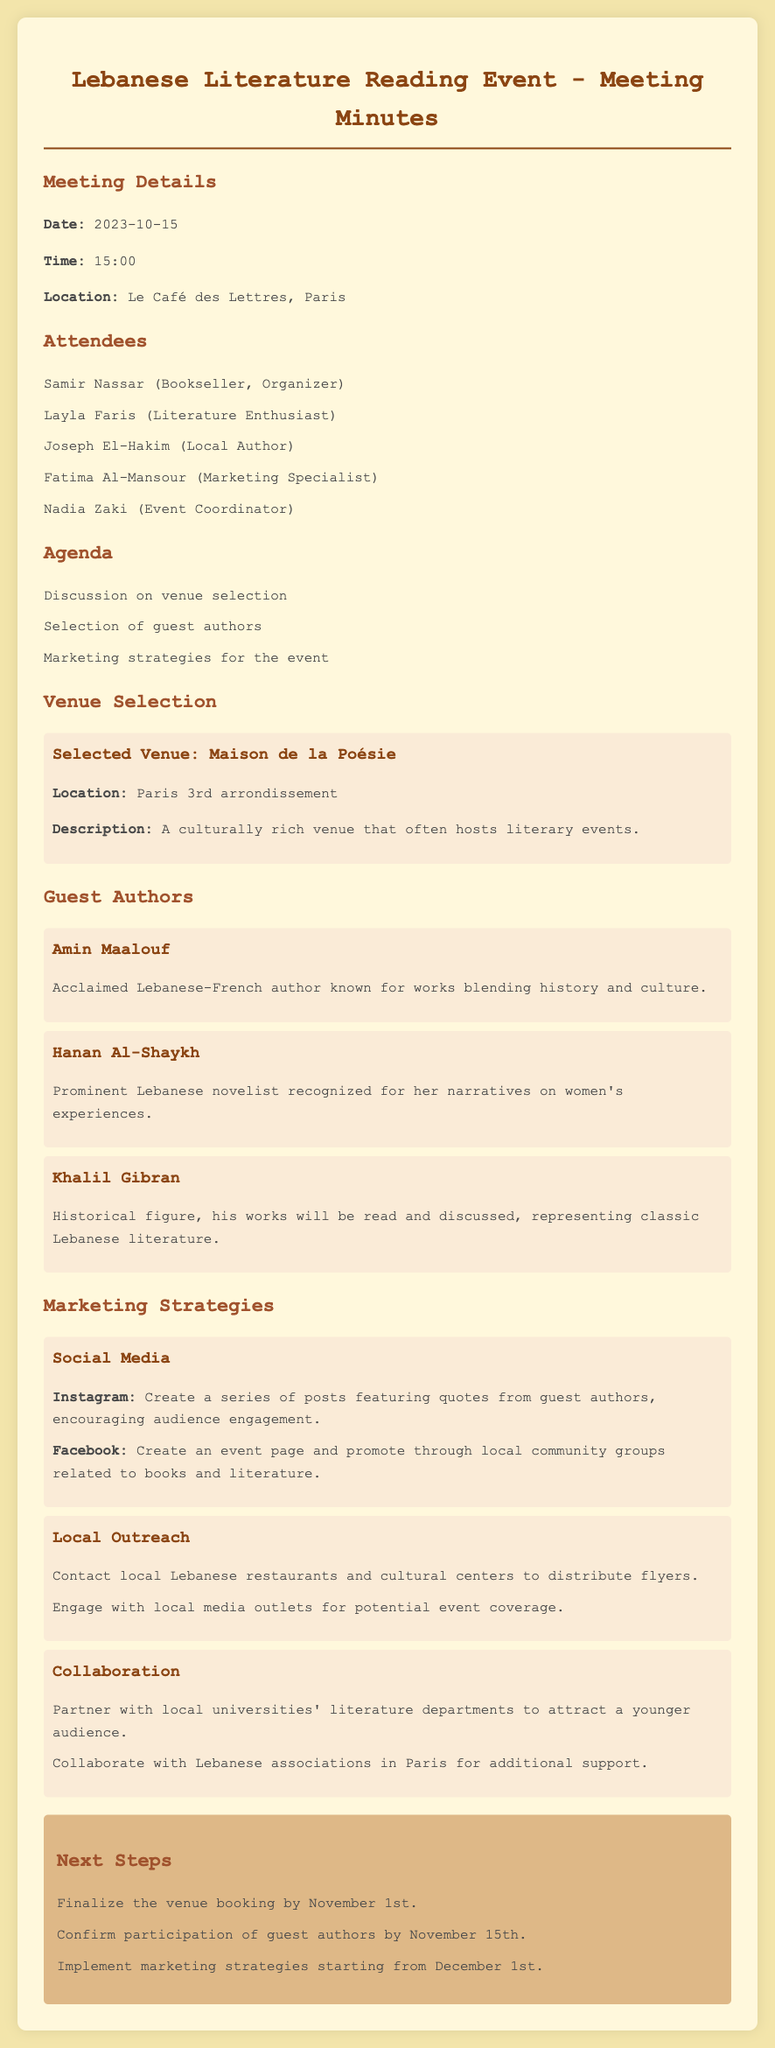what is the date of the meeting? The date of the meeting is mentioned in the 'Meeting Details' section of the document.
Answer: 2023-10-15 what is the selected venue for the event? The selected venue is outlined specifically in the 'Venue Selection' section.
Answer: Maison de la Poésie who is an acclaimed Lebanese-French author mentioned? The list of guest authors includes one described as an acclaimed Lebanese-French author.
Answer: Amin Maalouf what is one marketing strategy proposed? The document lists various marketing strategies; one example is provided under 'Marketing Strategies.'
Answer: Social Media by what date should the venue booking be finalized? The timeline for finalizing the venue booking is stated in the 'Next Steps' section of the document.
Answer: November 1st what type of event is being organized? The general nature of the gathering is stated in the title of the document and agenda.
Answer: Reading event what is the location of the meeting? The location is specified in the 'Meeting Details' section of the document.
Answer: Le Café des Lettres, Paris who is the event coordinator mentioned? The attendees include various roles, one of which is listed as the event coordinator.
Answer: Nadia Zaki 